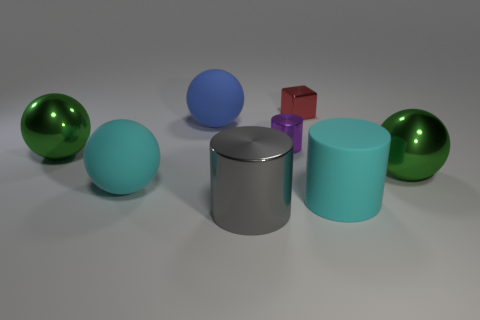The cyan cylinder that is made of the same material as the large blue sphere is what size?
Offer a very short reply. Large. How many large matte objects are the same color as the rubber cylinder?
Offer a terse response. 1. Is the number of big gray cylinders behind the big gray shiny thing less than the number of purple cylinders on the left side of the purple cylinder?
Make the answer very short. No. Do the shiny object that is in front of the cyan cylinder and the tiny red thing have the same shape?
Provide a succinct answer. No. Is there any other thing that has the same material as the big cyan cylinder?
Keep it short and to the point. Yes. Is the large green ball right of the red metal block made of the same material as the large gray thing?
Provide a succinct answer. Yes. What is the cylinder to the left of the small purple cylinder on the left side of the large green object that is to the right of the big cyan ball made of?
Give a very brief answer. Metal. How many other objects are there of the same shape as the big gray thing?
Give a very brief answer. 2. What is the color of the large metallic thing to the right of the small cylinder?
Ensure brevity in your answer.  Green. How many small red shiny cubes are left of the cylinder behind the big rubber object that is on the right side of the tiny red metallic block?
Your answer should be compact. 0. 